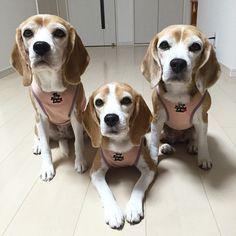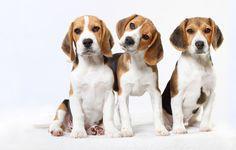The first image is the image on the left, the second image is the image on the right. Evaluate the accuracy of this statement regarding the images: "In one image there is a single puppy sitting on the ground.". Is it true? Answer yes or no. No. The first image is the image on the left, the second image is the image on the right. Considering the images on both sides, is "There is one puppy sitting by itself in one of the images." valid? Answer yes or no. No. 